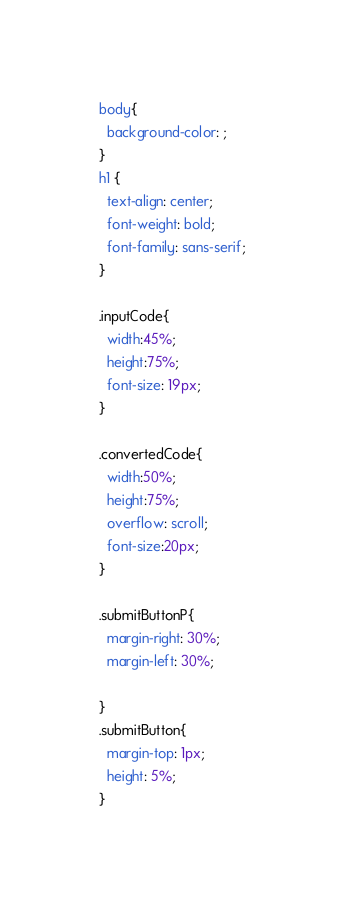<code> <loc_0><loc_0><loc_500><loc_500><_CSS_>body{
  background-color: ;
}
h1 {
  text-align: center;
  font-weight: bold;
  font-family: sans-serif;
}

.inputCode{
  width:45%;
  height:75%;
  font-size: 19px;
}

.convertedCode{
  width:50%;
  height:75%;
  overflow: scroll;
  font-size:20px;
}

.submitButtonP{
  margin-right: 30%;
  margin-left: 30%;

}
.submitButton{
  margin-top: 1px;
  height: 5%;
}
</code> 